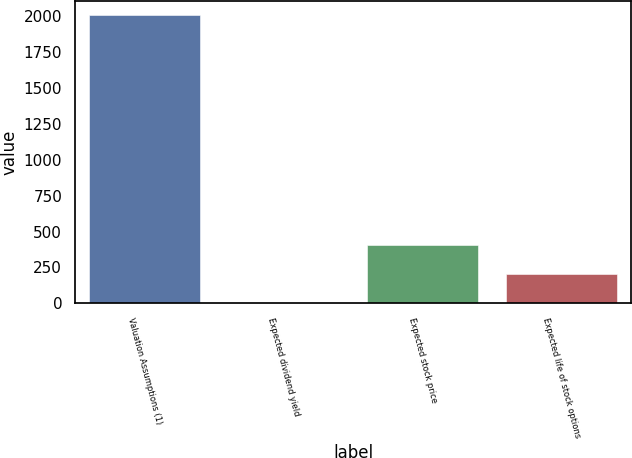<chart> <loc_0><loc_0><loc_500><loc_500><bar_chart><fcel>Valuation Assumptions (1)<fcel>Expected dividend yield<fcel>Expected stock price<fcel>Expected life of stock options<nl><fcel>2009<fcel>1.6<fcel>403.08<fcel>202.34<nl></chart> 